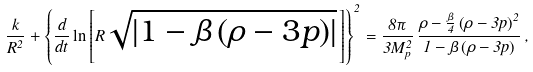Convert formula to latex. <formula><loc_0><loc_0><loc_500><loc_500>\frac { k } { R ^ { 2 } } + \left \{ \frac { d } { d t } \ln \left [ R \sqrt { \left | 1 - \beta \left ( \rho - 3 p \right ) \right | } \, \right ] \right \} ^ { 2 } = \frac { 8 \pi } { 3 M _ { p } ^ { 2 } } \, \frac { \rho - \frac { \beta } { 4 } \left ( \rho - 3 p \right ) ^ { 2 } } { 1 - \beta \left ( \rho - 3 p \right ) } \, ,</formula> 